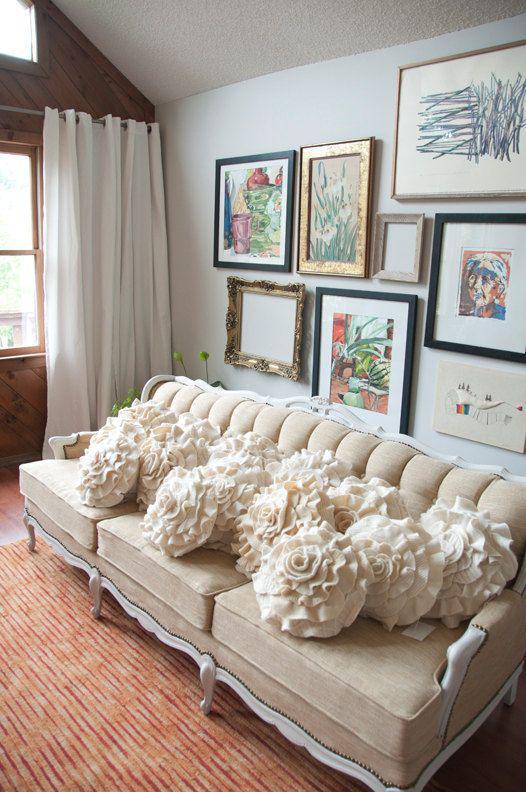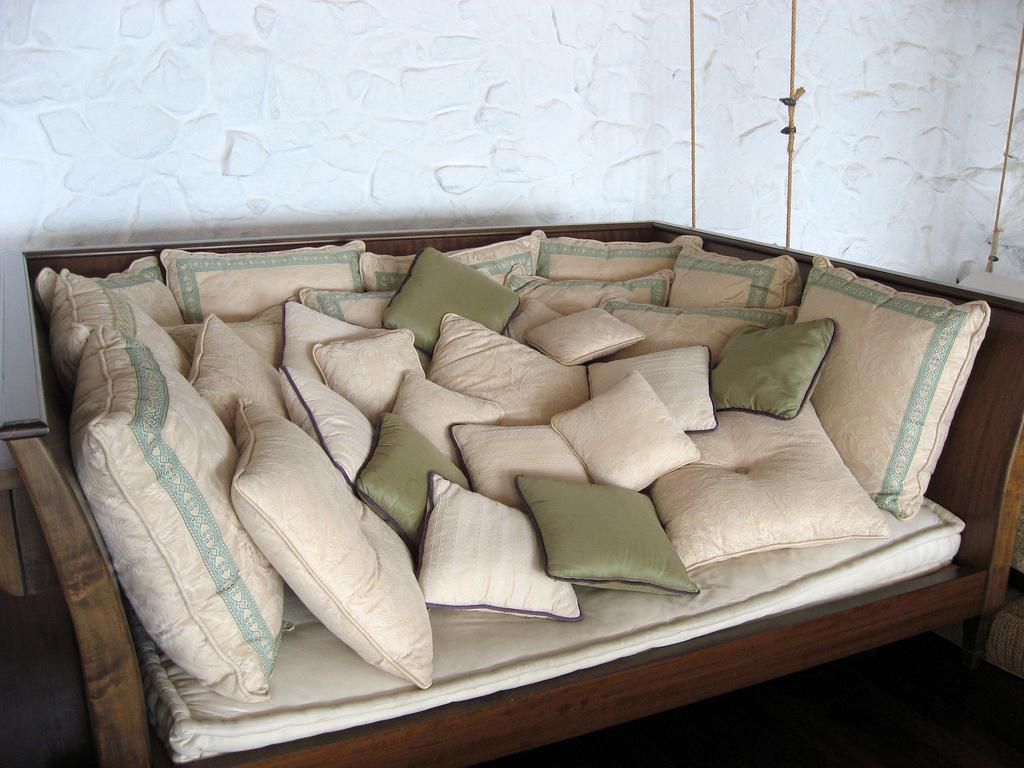The first image is the image on the left, the second image is the image on the right. Considering the images on both sides, is "There are more than 5 frames on the wall in the image on the left." valid? Answer yes or no. Yes. 